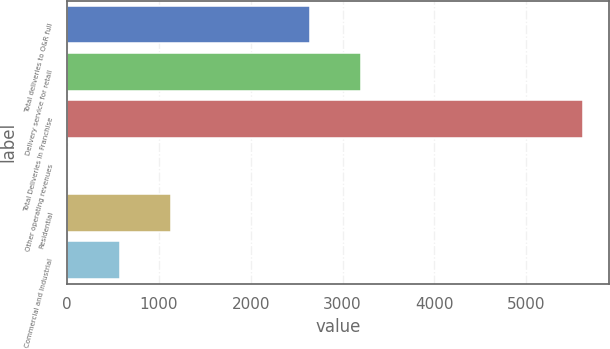<chart> <loc_0><loc_0><loc_500><loc_500><bar_chart><fcel>Total deliveries to O&R full<fcel>Delivery service for retail<fcel>Total Deliveries In Franchise<fcel>Other operating revenues<fcel>Residential<fcel>Commercial and Industrial<nl><fcel>2643<fcel>3203.5<fcel>5617<fcel>12<fcel>1133<fcel>572.5<nl></chart> 